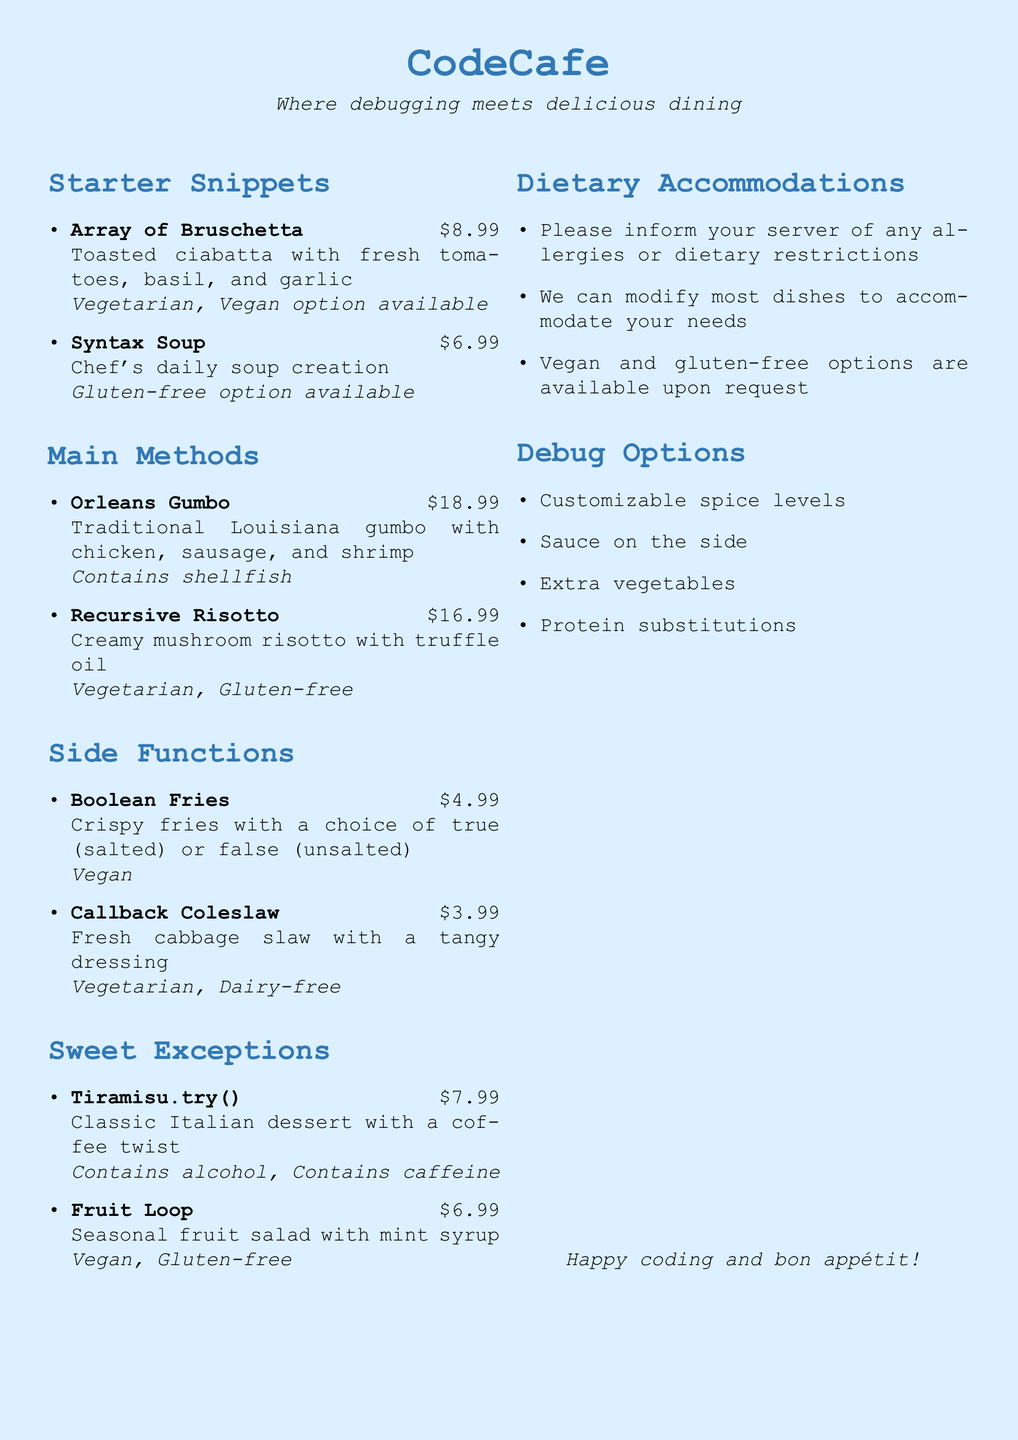What is the price of Array of Bruschetta? The price is listed next to the dish name in the menu.
Answer: $8.99 What dietary options are available for the Recursive Risotto? The dietary options are specified within the description of the dish.
Answer: Vegetarian, Gluten-free Which dish contains shellfish? The information is included in the description of the dish that contains shellfish.
Answer: Orleans Gumbo How many starter snippets are listed in the menu? The number of items can be counted from the starters section of the menu.
Answer: 2 What is the main theme of the restaurant as stated in the document? The theme is mentioned in the center of the document as part of the restaurant's branding.
Answer: Where debugging meets delicious dining What options can be customized according to the Debug Options section? The Debug Options section lists specific aspects of dishes that can be modified.
Answer: Customizable spice levels, Sauce on the side, Extra vegetables, Protein substitutions What type of dessert is Tiramisu.try()? The dessert is categorized within the Sweet Exceptions section of the menu.
Answer: Classic Italian dessert What should customers inform their server about? This information is mentioned in the Dietary Accommodations section.
Answer: Allergies or dietary restrictions 